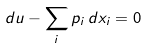<formula> <loc_0><loc_0><loc_500><loc_500>d u - \sum _ { i } p _ { i } \, d x _ { i } = 0</formula> 